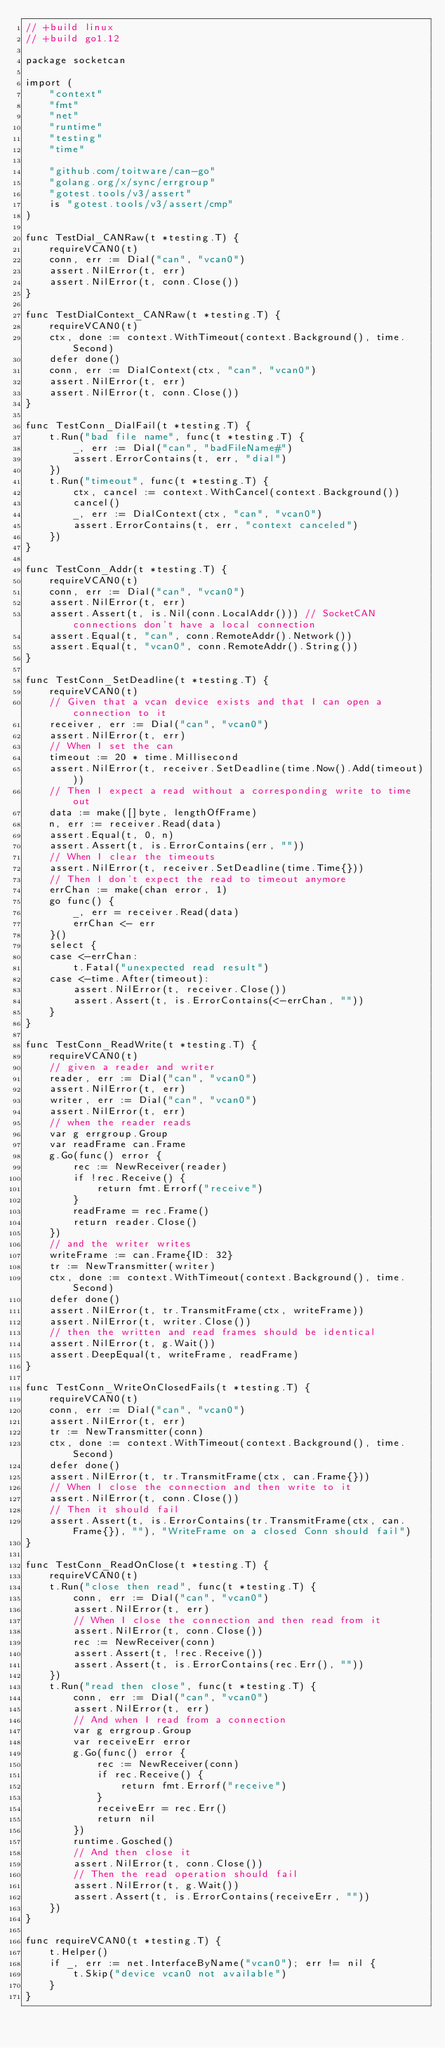<code> <loc_0><loc_0><loc_500><loc_500><_Go_>// +build linux
// +build go1.12

package socketcan

import (
	"context"
	"fmt"
	"net"
	"runtime"
	"testing"
	"time"

	"github.com/toitware/can-go"
	"golang.org/x/sync/errgroup"
	"gotest.tools/v3/assert"
	is "gotest.tools/v3/assert/cmp"
)

func TestDial_CANRaw(t *testing.T) {
	requireVCAN0(t)
	conn, err := Dial("can", "vcan0")
	assert.NilError(t, err)
	assert.NilError(t, conn.Close())
}

func TestDialContext_CANRaw(t *testing.T) {
	requireVCAN0(t)
	ctx, done := context.WithTimeout(context.Background(), time.Second)
	defer done()
	conn, err := DialContext(ctx, "can", "vcan0")
	assert.NilError(t, err)
	assert.NilError(t, conn.Close())
}

func TestConn_DialFail(t *testing.T) {
	t.Run("bad file name", func(t *testing.T) {
		_, err := Dial("can", "badFileName#")
		assert.ErrorContains(t, err, "dial")
	})
	t.Run("timeout", func(t *testing.T) {
		ctx, cancel := context.WithCancel(context.Background())
		cancel()
		_, err := DialContext(ctx, "can", "vcan0")
		assert.ErrorContains(t, err, "context canceled")
	})
}

func TestConn_Addr(t *testing.T) {
	requireVCAN0(t)
	conn, err := Dial("can", "vcan0")
	assert.NilError(t, err)
	assert.Assert(t, is.Nil(conn.LocalAddr())) // SocketCAN connections don't have a local connection
	assert.Equal(t, "can", conn.RemoteAddr().Network())
	assert.Equal(t, "vcan0", conn.RemoteAddr().String())
}

func TestConn_SetDeadline(t *testing.T) {
	requireVCAN0(t)
	// Given that a vcan device exists and that I can open a connection to it
	receiver, err := Dial("can", "vcan0")
	assert.NilError(t, err)
	// When I set the can
	timeout := 20 * time.Millisecond
	assert.NilError(t, receiver.SetDeadline(time.Now().Add(timeout)))
	// Then I expect a read without a corresponding write to time out
	data := make([]byte, lengthOfFrame)
	n, err := receiver.Read(data)
	assert.Equal(t, 0, n)
	assert.Assert(t, is.ErrorContains(err, ""))
	// When I clear the timeouts
	assert.NilError(t, receiver.SetDeadline(time.Time{}))
	// Then I don't expect the read to timeout anymore
	errChan := make(chan error, 1)
	go func() {
		_, err = receiver.Read(data)
		errChan <- err
	}()
	select {
	case <-errChan:
		t.Fatal("unexpected read result")
	case <-time.After(timeout):
		assert.NilError(t, receiver.Close())
		assert.Assert(t, is.ErrorContains(<-errChan, ""))
	}
}

func TestConn_ReadWrite(t *testing.T) {
	requireVCAN0(t)
	// given a reader and writer
	reader, err := Dial("can", "vcan0")
	assert.NilError(t, err)
	writer, err := Dial("can", "vcan0")
	assert.NilError(t, err)
	// when the reader reads
	var g errgroup.Group
	var readFrame can.Frame
	g.Go(func() error {
		rec := NewReceiver(reader)
		if !rec.Receive() {
			return fmt.Errorf("receive")
		}
		readFrame = rec.Frame()
		return reader.Close()
	})
	// and the writer writes
	writeFrame := can.Frame{ID: 32}
	tr := NewTransmitter(writer)
	ctx, done := context.WithTimeout(context.Background(), time.Second)
	defer done()
	assert.NilError(t, tr.TransmitFrame(ctx, writeFrame))
	assert.NilError(t, writer.Close())
	// then the written and read frames should be identical
	assert.NilError(t, g.Wait())
	assert.DeepEqual(t, writeFrame, readFrame)
}

func TestConn_WriteOnClosedFails(t *testing.T) {
	requireVCAN0(t)
	conn, err := Dial("can", "vcan0")
	assert.NilError(t, err)
	tr := NewTransmitter(conn)
	ctx, done := context.WithTimeout(context.Background(), time.Second)
	defer done()
	assert.NilError(t, tr.TransmitFrame(ctx, can.Frame{}))
	// When I close the connection and then write to it
	assert.NilError(t, conn.Close())
	// Then it should fail
	assert.Assert(t, is.ErrorContains(tr.TransmitFrame(ctx, can.Frame{}), ""), "WriteFrame on a closed Conn should fail")
}

func TestConn_ReadOnClose(t *testing.T) {
	requireVCAN0(t)
	t.Run("close then read", func(t *testing.T) {
		conn, err := Dial("can", "vcan0")
		assert.NilError(t, err)
		// When I close the connection and then read from it
		assert.NilError(t, conn.Close())
		rec := NewReceiver(conn)
		assert.Assert(t, !rec.Receive())
		assert.Assert(t, is.ErrorContains(rec.Err(), ""))
	})
	t.Run("read then close", func(t *testing.T) {
		conn, err := Dial("can", "vcan0")
		assert.NilError(t, err)
		// And when I read from a connection
		var g errgroup.Group
		var receiveErr error
		g.Go(func() error {
			rec := NewReceiver(conn)
			if rec.Receive() {
				return fmt.Errorf("receive")
			}
			receiveErr = rec.Err()
			return nil
		})
		runtime.Gosched()
		// And then close it
		assert.NilError(t, conn.Close())
		// Then the read operation should fail
		assert.NilError(t, g.Wait())
		assert.Assert(t, is.ErrorContains(receiveErr, ""))
	})
}

func requireVCAN0(t *testing.T) {
	t.Helper()
	if _, err := net.InterfaceByName("vcan0"); err != nil {
		t.Skip("device vcan0 not available")
	}
}
</code> 